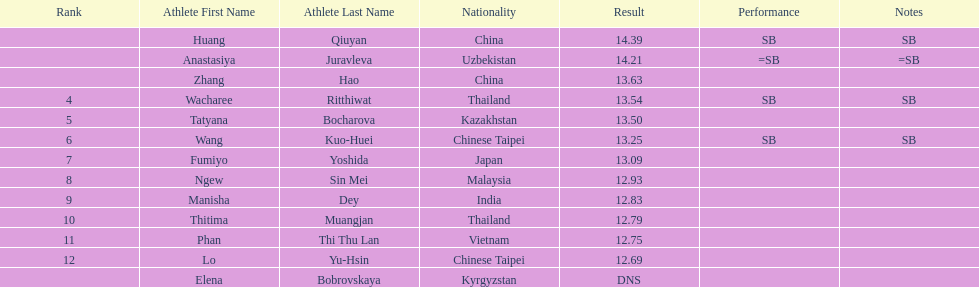How many athletes had a better result than tatyana bocharova? 4. 